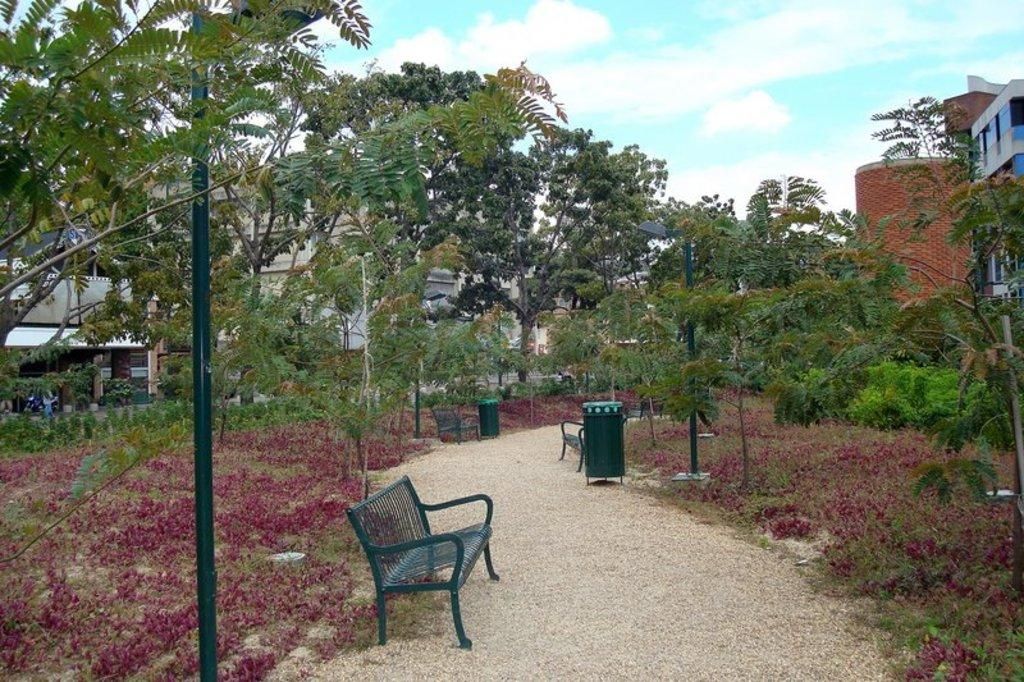What type of seating is available in the image? There are benches in the image. What other objects can be seen in the image? There are dustbins and poles on the walkway in the image. What is located on the left side of the benches? There are plants, trees, and buildings on the left side of the benches in the image. What part of the natural environment is visible in the image? The sky is visible in the image. What type of toys can be seen in the image? There are no toys present in the image. What time of day is it in the image? The time of day cannot be determined from the image alone. 